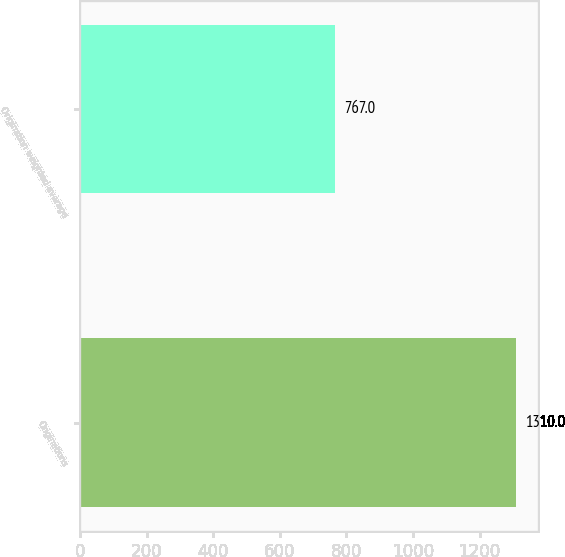Convert chart. <chart><loc_0><loc_0><loc_500><loc_500><bar_chart><fcel>Originations<fcel>Origination weighted average<nl><fcel>1310<fcel>767<nl></chart> 